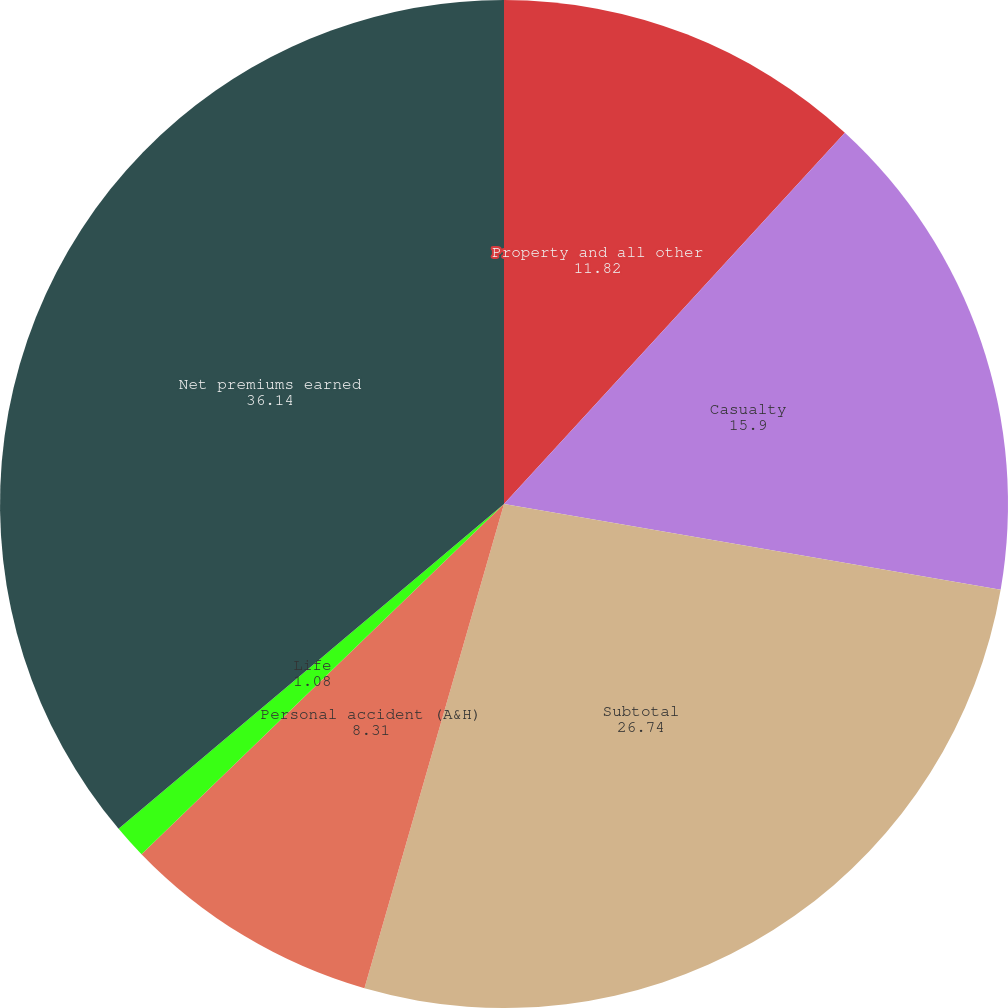Convert chart. <chart><loc_0><loc_0><loc_500><loc_500><pie_chart><fcel>Property and all other<fcel>Casualty<fcel>Subtotal<fcel>Personal accident (A&H)<fcel>Life<fcel>Net premiums earned<nl><fcel>11.82%<fcel>15.9%<fcel>26.74%<fcel>8.31%<fcel>1.08%<fcel>36.14%<nl></chart> 